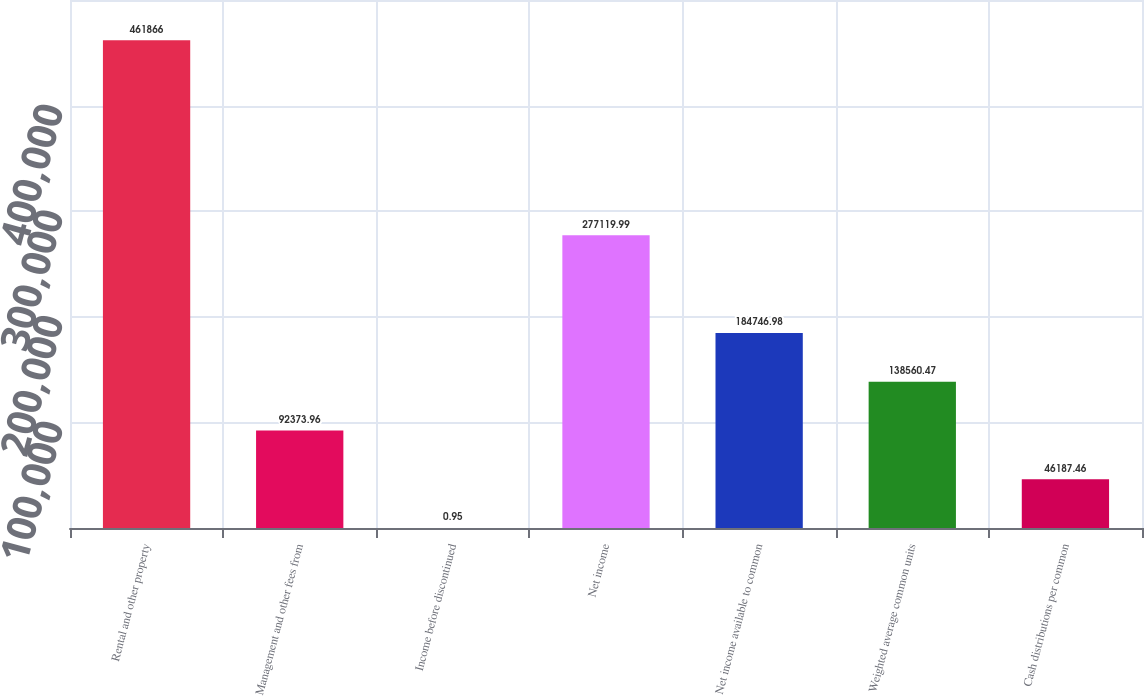Convert chart to OTSL. <chart><loc_0><loc_0><loc_500><loc_500><bar_chart><fcel>Rental and other property<fcel>Management and other fees from<fcel>Income before discontinued<fcel>Net income<fcel>Net income available to common<fcel>Weighted average common units<fcel>Cash distributions per common<nl><fcel>461866<fcel>92374<fcel>0.95<fcel>277120<fcel>184747<fcel>138560<fcel>46187.5<nl></chart> 